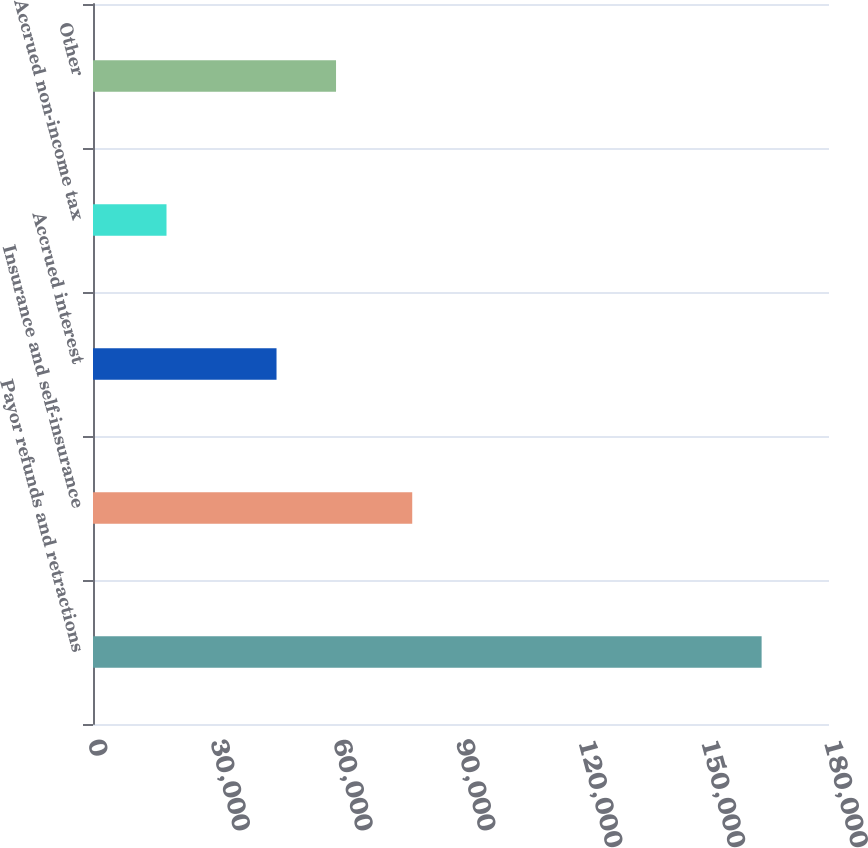<chart> <loc_0><loc_0><loc_500><loc_500><bar_chart><fcel>Payor refunds and retractions<fcel>Insurance and self-insurance<fcel>Accrued interest<fcel>Accrued non-income tax<fcel>Other<nl><fcel>163520<fcel>78073<fcel>44884<fcel>17976<fcel>59438.4<nl></chart> 